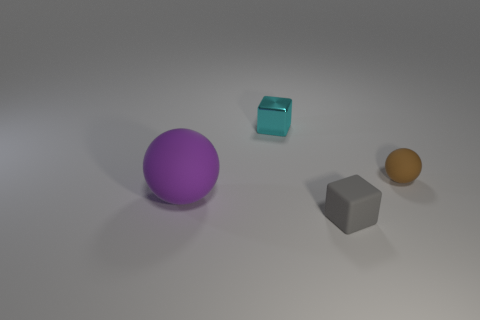Which object is closest to the camera? The grey cube appears to be the closest object to the camera based on this perspective. 